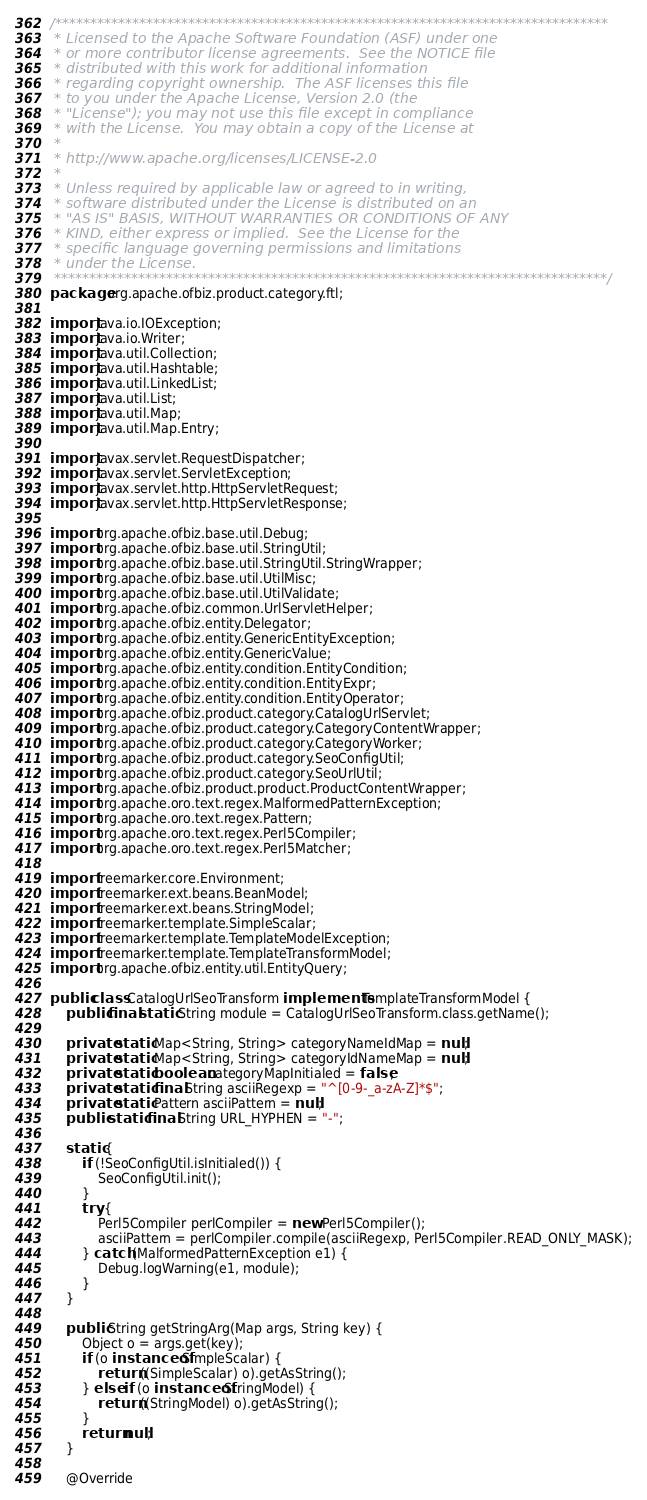<code> <loc_0><loc_0><loc_500><loc_500><_Java_>/*******************************************************************************
 * Licensed to the Apache Software Foundation (ASF) under one
 * or more contributor license agreements.  See the NOTICE file
 * distributed with this work for additional information
 * regarding copyright ownership.  The ASF licenses this file
 * to you under the Apache License, Version 2.0 (the
 * "License"); you may not use this file except in compliance
 * with the License.  You may obtain a copy of the License at
 *
 * http://www.apache.org/licenses/LICENSE-2.0
 *
 * Unless required by applicable law or agreed to in writing,
 * software distributed under the License is distributed on an
 * "AS IS" BASIS, WITHOUT WARRANTIES OR CONDITIONS OF ANY
 * KIND, either express or implied.  See the License for the
 * specific language governing permissions and limitations
 * under the License.
 *******************************************************************************/
package org.apache.ofbiz.product.category.ftl;

import java.io.IOException;
import java.io.Writer;
import java.util.Collection;
import java.util.Hashtable;
import java.util.LinkedList;
import java.util.List;
import java.util.Map;
import java.util.Map.Entry;

import javax.servlet.RequestDispatcher;
import javax.servlet.ServletException;
import javax.servlet.http.HttpServletRequest;
import javax.servlet.http.HttpServletResponse;

import org.apache.ofbiz.base.util.Debug;
import org.apache.ofbiz.base.util.StringUtil;
import org.apache.ofbiz.base.util.StringUtil.StringWrapper;
import org.apache.ofbiz.base.util.UtilMisc;
import org.apache.ofbiz.base.util.UtilValidate;
import org.apache.ofbiz.common.UrlServletHelper;
import org.apache.ofbiz.entity.Delegator;
import org.apache.ofbiz.entity.GenericEntityException;
import org.apache.ofbiz.entity.GenericValue;
import org.apache.ofbiz.entity.condition.EntityCondition;
import org.apache.ofbiz.entity.condition.EntityExpr;
import org.apache.ofbiz.entity.condition.EntityOperator;
import org.apache.ofbiz.product.category.CatalogUrlServlet;
import org.apache.ofbiz.product.category.CategoryContentWrapper;
import org.apache.ofbiz.product.category.CategoryWorker;
import org.apache.ofbiz.product.category.SeoConfigUtil;
import org.apache.ofbiz.product.category.SeoUrlUtil;
import org.apache.ofbiz.product.product.ProductContentWrapper;
import org.apache.oro.text.regex.MalformedPatternException;
import org.apache.oro.text.regex.Pattern;
import org.apache.oro.text.regex.Perl5Compiler;
import org.apache.oro.text.regex.Perl5Matcher;

import freemarker.core.Environment;
import freemarker.ext.beans.BeanModel;
import freemarker.ext.beans.StringModel;
import freemarker.template.SimpleScalar;
import freemarker.template.TemplateModelException;
import freemarker.template.TemplateTransformModel;
import org.apache.ofbiz.entity.util.EntityQuery;

public class CatalogUrlSeoTransform implements TemplateTransformModel {
    public final static String module = CatalogUrlSeoTransform.class.getName();
    
    private static Map<String, String> categoryNameIdMap = null;
    private static Map<String, String> categoryIdNameMap = null;
    private static boolean categoryMapInitialed = false;
    private static final String asciiRegexp = "^[0-9-_a-zA-Z]*$";
    private static Pattern asciiPattern = null;
    public static final String URL_HYPHEN = "-";

    static {
        if (!SeoConfigUtil.isInitialed()) {
            SeoConfigUtil.init();
        }
        try {
            Perl5Compiler perlCompiler = new Perl5Compiler();
            asciiPattern = perlCompiler.compile(asciiRegexp, Perl5Compiler.READ_ONLY_MASK);
        } catch (MalformedPatternException e1) {
            Debug.logWarning(e1, module);
        }
    }
    
    public String getStringArg(Map args, String key) {
        Object o = args.get(key);
        if (o instanceof SimpleScalar) {
            return ((SimpleScalar) o).getAsString();
        } else if (o instanceof StringModel) {
            return ((StringModel) o).getAsString();
        }
        return null;
    }

    @Override</code> 